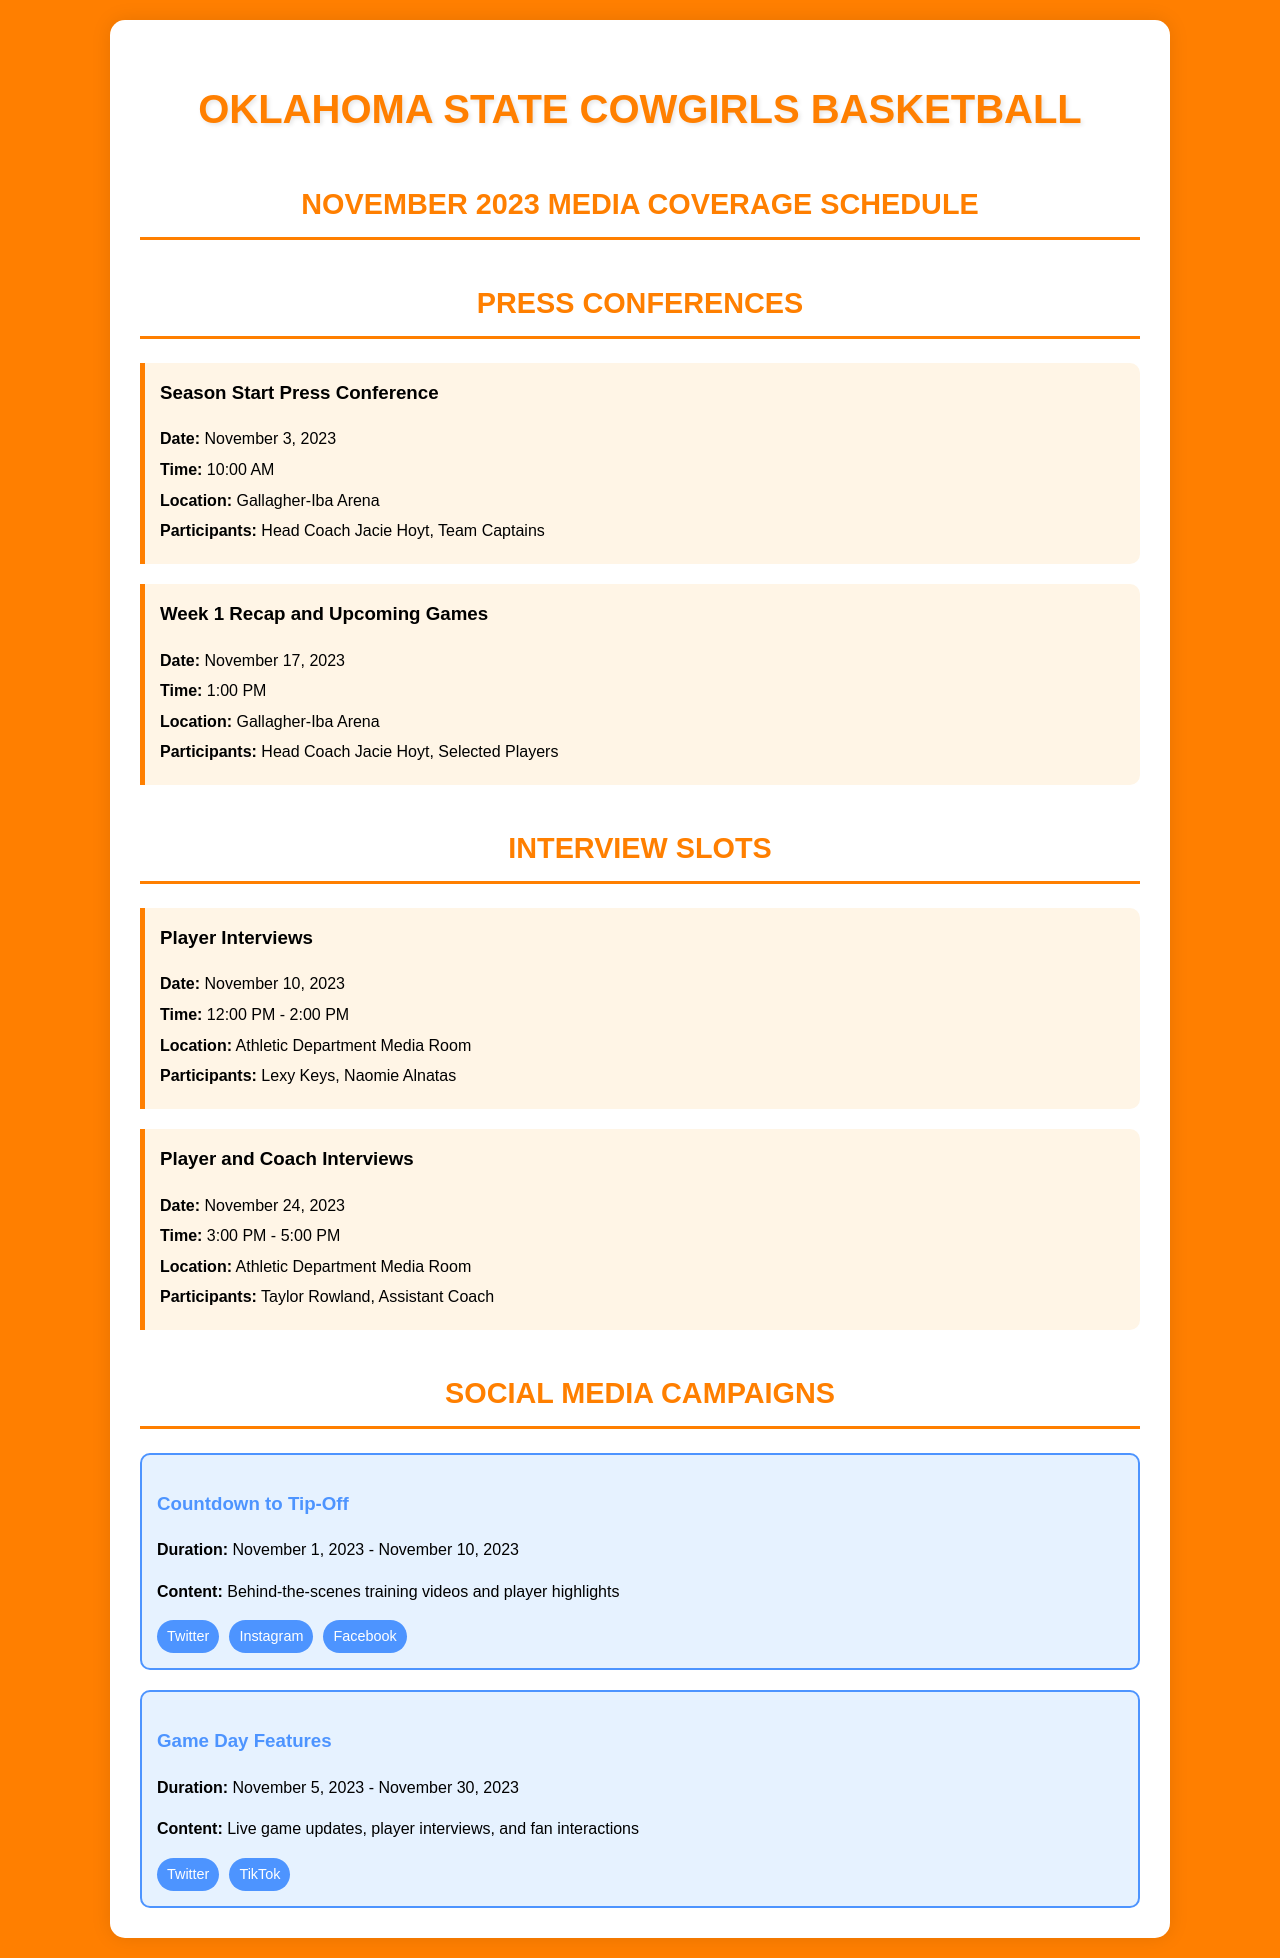What is the date of the season start press conference? The date for the season start press conference is specifically mentioned in the schedule as November 3, 2023.
Answer: November 3, 2023 What time is the week 1 recap press conference scheduled for? The time for the week 1 recap and upcoming games press conference is provided as 1:00 PM on November 17, 2023.
Answer: 1:00 PM Who will participate in the player interviews on November 10? The participants in the player interviews scheduled for November 10, 2023, are specifically listed as Lexy Keys and Naomie Alnatas.
Answer: Lexy Keys, Naomie Alnatas What is the duration of the "Game Day Features" social media campaign? The duration of the "Game Day Features" social media campaign is mentioned as from November 5, 2023, to November 30, 2023.
Answer: November 5, 2023 - November 30, 2023 What event is scheduled for November 24, 2023? The event scheduled for November 24, 2023, is specifically titled "Player and Coach Interviews."
Answer: Player and Coach Interviews How many interview slots are mentioned in the schedule? The schedule includes two specific interview slots that are clearly outlined in the document.
Answer: Two 